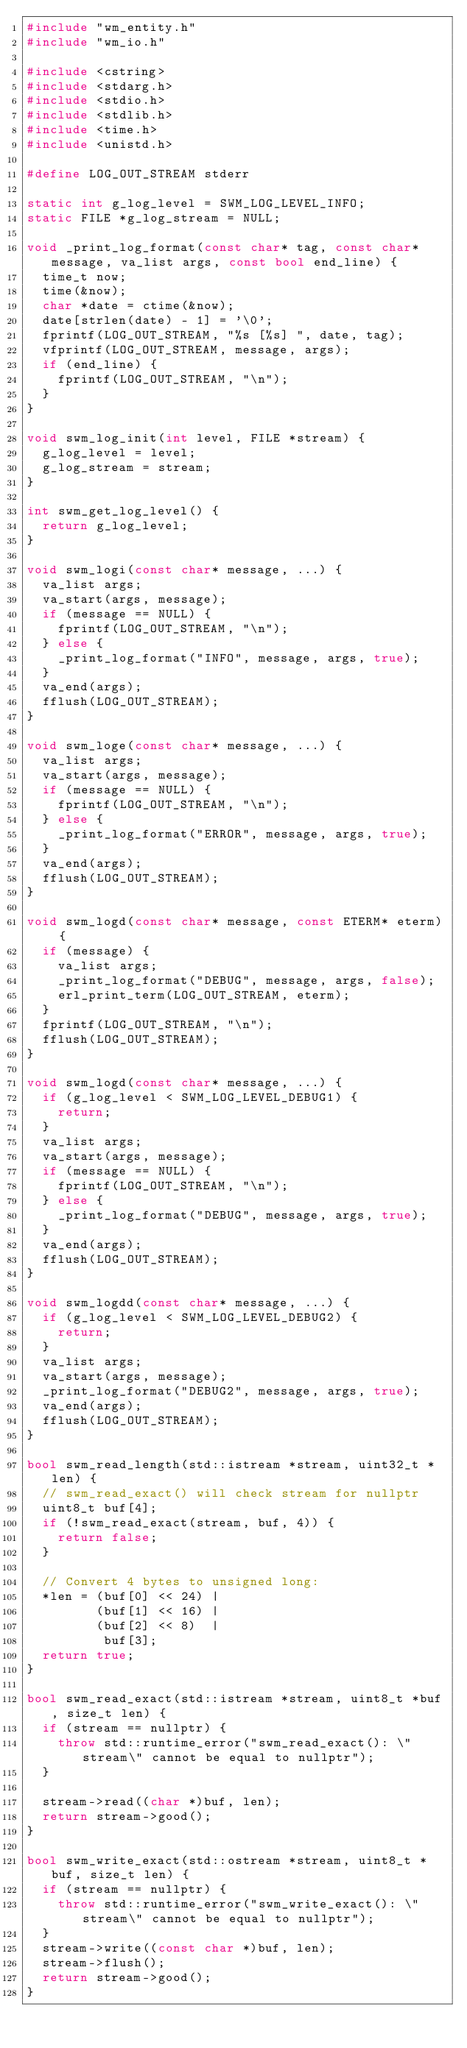Convert code to text. <code><loc_0><loc_0><loc_500><loc_500><_C++_>#include "wm_entity.h"
#include "wm_io.h"

#include <cstring>
#include <stdarg.h>
#include <stdio.h>
#include <stdlib.h>
#include <time.h>
#include <unistd.h>

#define LOG_OUT_STREAM stderr

static int g_log_level = SWM_LOG_LEVEL_INFO;
static FILE *g_log_stream = NULL;

void _print_log_format(const char* tag, const char* message, va_list args, const bool end_line) {
  time_t now;
  time(&now);
  char *date = ctime(&now);
  date[strlen(date) - 1] = '\0';
  fprintf(LOG_OUT_STREAM, "%s [%s] ", date, tag);
  vfprintf(LOG_OUT_STREAM, message, args);
  if (end_line) {
    fprintf(LOG_OUT_STREAM, "\n");
  }
}

void swm_log_init(int level, FILE *stream) {
  g_log_level = level;
  g_log_stream = stream;
}

int swm_get_log_level() {
  return g_log_level;
}

void swm_logi(const char* message, ...) {
  va_list args;
  va_start(args, message);
  if (message == NULL) {
    fprintf(LOG_OUT_STREAM, "\n");
  } else {
    _print_log_format("INFO", message, args, true);
  }
  va_end(args);
  fflush(LOG_OUT_STREAM);
}

void swm_loge(const char* message, ...) {
  va_list args;
  va_start(args, message);
  if (message == NULL) {
    fprintf(LOG_OUT_STREAM, "\n");
  } else {
    _print_log_format("ERROR", message, args, true);
  }
  va_end(args);
  fflush(LOG_OUT_STREAM);
}

void swm_logd(const char* message, const ETERM* eterm) {
  if (message) {
    va_list args;
    _print_log_format("DEBUG", message, args, false);
    erl_print_term(LOG_OUT_STREAM, eterm);
  }
  fprintf(LOG_OUT_STREAM, "\n");
  fflush(LOG_OUT_STREAM);
}

void swm_logd(const char* message, ...) {
  if (g_log_level < SWM_LOG_LEVEL_DEBUG1) {
    return;
  }
  va_list args;
  va_start(args, message);
  if (message == NULL) {
    fprintf(LOG_OUT_STREAM, "\n");
  } else {
    _print_log_format("DEBUG", message, args, true);
  }
  va_end(args);
  fflush(LOG_OUT_STREAM);
}

void swm_logdd(const char* message, ...) {
  if (g_log_level < SWM_LOG_LEVEL_DEBUG2) {
    return;
  }
  va_list args;
  va_start(args, message);
  _print_log_format("DEBUG2", message, args, true);
  va_end(args);
  fflush(LOG_OUT_STREAM);
}

bool swm_read_length(std::istream *stream, uint32_t *len) {
  // swm_read_exact() will check stream for nullptr
  uint8_t buf[4];
  if (!swm_read_exact(stream, buf, 4)) {
    return false;
  }

  // Convert 4 bytes to unsigned long:
  *len = (buf[0] << 24) |
         (buf[1] << 16) |
         (buf[2] << 8)  |
          buf[3];
  return true;
}

bool swm_read_exact(std::istream *stream, uint8_t *buf, size_t len) {
  if (stream == nullptr) {
    throw std::runtime_error("swm_read_exact(): \"stream\" cannot be equal to nullptr");
  }

  stream->read((char *)buf, len);
  return stream->good();
}

bool swm_write_exact(std::ostream *stream, uint8_t *buf, size_t len) {
  if (stream == nullptr) {
    throw std::runtime_error("swm_write_exact(): \"stream\" cannot be equal to nullptr");
  }
  stream->write((const char *)buf, len);
  stream->flush();
  return stream->good();
}
</code> 